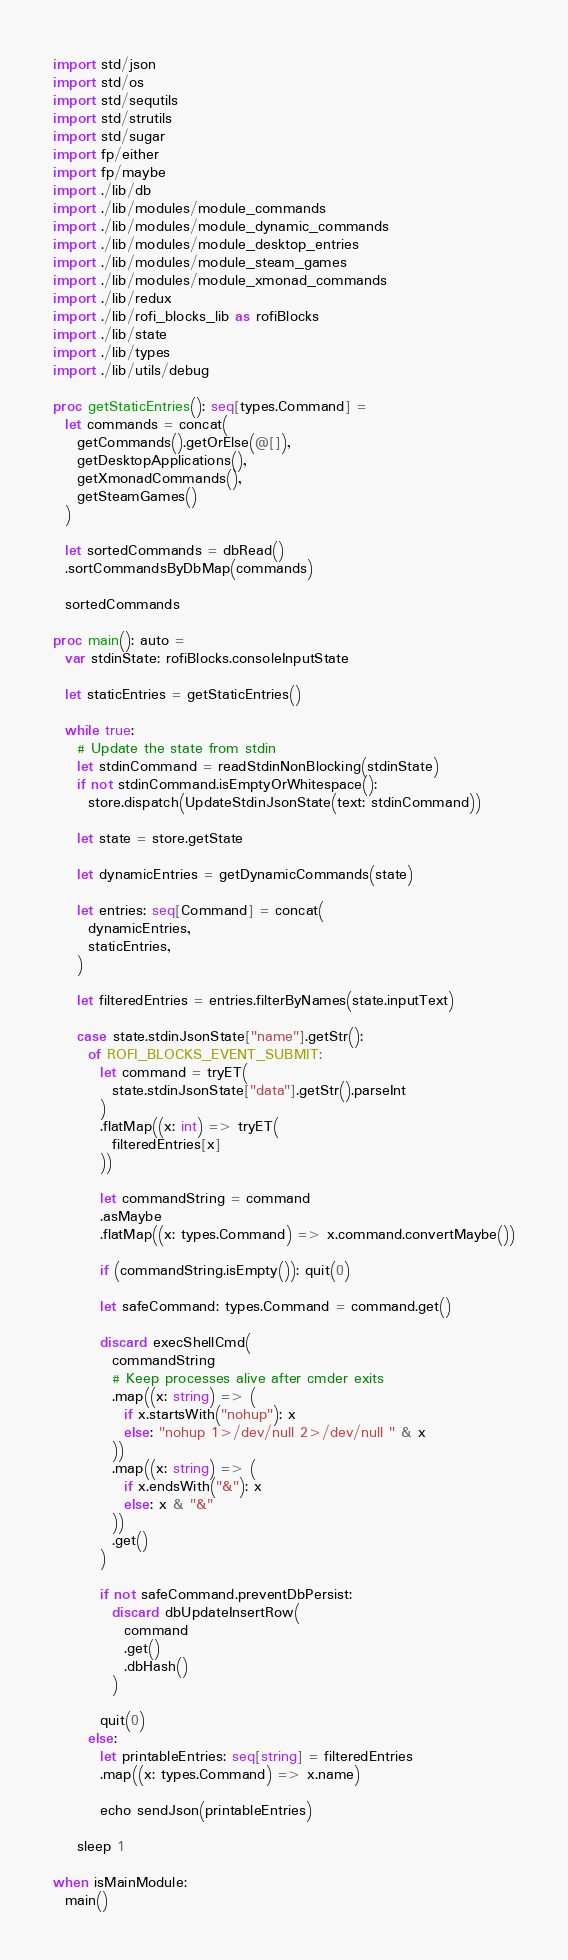<code> <loc_0><loc_0><loc_500><loc_500><_Nim_>import std/json
import std/os
import std/sequtils
import std/strutils
import std/sugar
import fp/either
import fp/maybe
import ./lib/db
import ./lib/modules/module_commands
import ./lib/modules/module_dynamic_commands
import ./lib/modules/module_desktop_entries
import ./lib/modules/module_steam_games
import ./lib/modules/module_xmonad_commands
import ./lib/redux
import ./lib/rofi_blocks_lib as rofiBlocks
import ./lib/state
import ./lib/types
import ./lib/utils/debug

proc getStaticEntries(): seq[types.Command] =
  let commands = concat(
    getCommands().getOrElse(@[]),
    getDesktopApplications(),
    getXmonadCommands(),
    getSteamGames()
  )

  let sortedCommands = dbRead()
  .sortCommandsByDbMap(commands)

  sortedCommands

proc main(): auto =
  var stdinState: rofiBlocks.consoleInputState

  let staticEntries = getStaticEntries()

  while true:
    # Update the state from stdin
    let stdinCommand = readStdinNonBlocking(stdinState)
    if not stdinCommand.isEmptyOrWhitespace():
      store.dispatch(UpdateStdinJsonState(text: stdinCommand))

    let state = store.getState

    let dynamicEntries = getDynamicCommands(state)

    let entries: seq[Command] = concat(
      dynamicEntries,
      staticEntries,
    )

    let filteredEntries = entries.filterByNames(state.inputText)

    case state.stdinJsonState["name"].getStr():
      of ROFI_BLOCKS_EVENT_SUBMIT:
        let command = tryET(
          state.stdinJsonState["data"].getStr().parseInt
        )
        .flatMap((x: int) => tryET(
          filteredEntries[x]
        ))

        let commandString = command
        .asMaybe
        .flatMap((x: types.Command) => x.command.convertMaybe())

        if (commandString.isEmpty()): quit(0)

        let safeCommand: types.Command = command.get()

        discard execShellCmd(
          commandString
          # Keep processes alive after cmder exits
          .map((x: string) => (
            if x.startsWith("nohup"): x
            else: "nohup 1>/dev/null 2>/dev/null " & x
          ))
          .map((x: string) => (
            if x.endsWith("&"): x
            else: x & "&"
          ))
          .get()
        )

        if not safeCommand.preventDbPersist:
          discard dbUpdateInsertRow(
            command
            .get()
            .dbHash()
          )

        quit(0)
      else:
        let printableEntries: seq[string] = filteredEntries
        .map((x: types.Command) => x.name)

        echo sendJson(printableEntries)

    sleep 1

when isMainModule:
  main()
</code> 